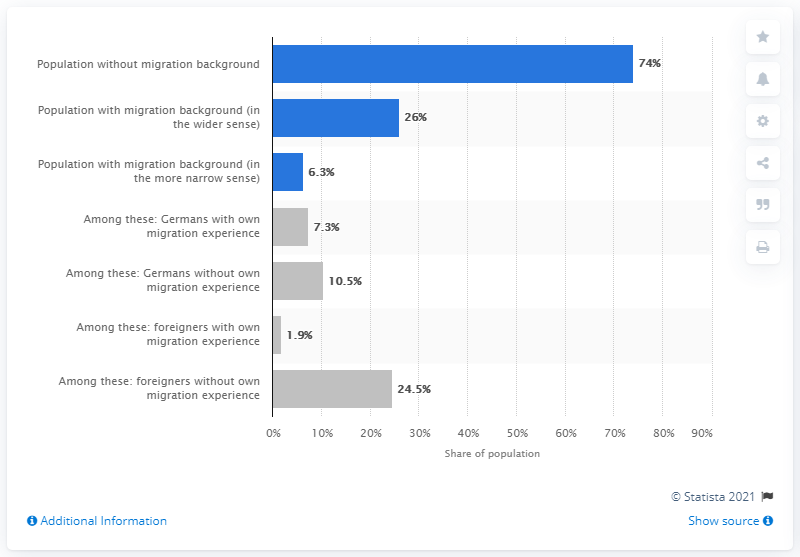Indicate a few pertinent items in this graphic. In 2019, approximately 26% of the population in Germany had a migration background. 